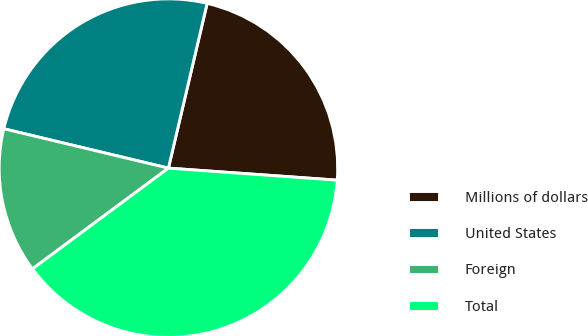<chart> <loc_0><loc_0><loc_500><loc_500><pie_chart><fcel>Millions of dollars<fcel>United States<fcel>Foreign<fcel>Total<nl><fcel>22.46%<fcel>24.94%<fcel>13.89%<fcel>38.72%<nl></chart> 